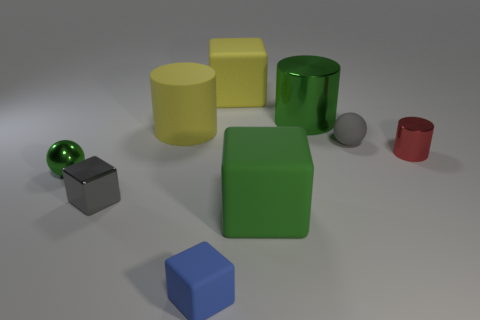Subtract all large yellow cylinders. How many cylinders are left? 2 Subtract all gray spheres. How many spheres are left? 1 Subtract all cubes. How many objects are left? 5 Subtract 3 blocks. How many blocks are left? 1 Subtract all gray cylinders. How many gray spheres are left? 1 Subtract all large red metallic things. Subtract all big green metal cylinders. How many objects are left? 8 Add 6 small green shiny things. How many small green shiny things are left? 7 Add 2 large matte objects. How many large matte objects exist? 5 Subtract 0 cyan blocks. How many objects are left? 9 Subtract all blue blocks. Subtract all cyan cylinders. How many blocks are left? 3 